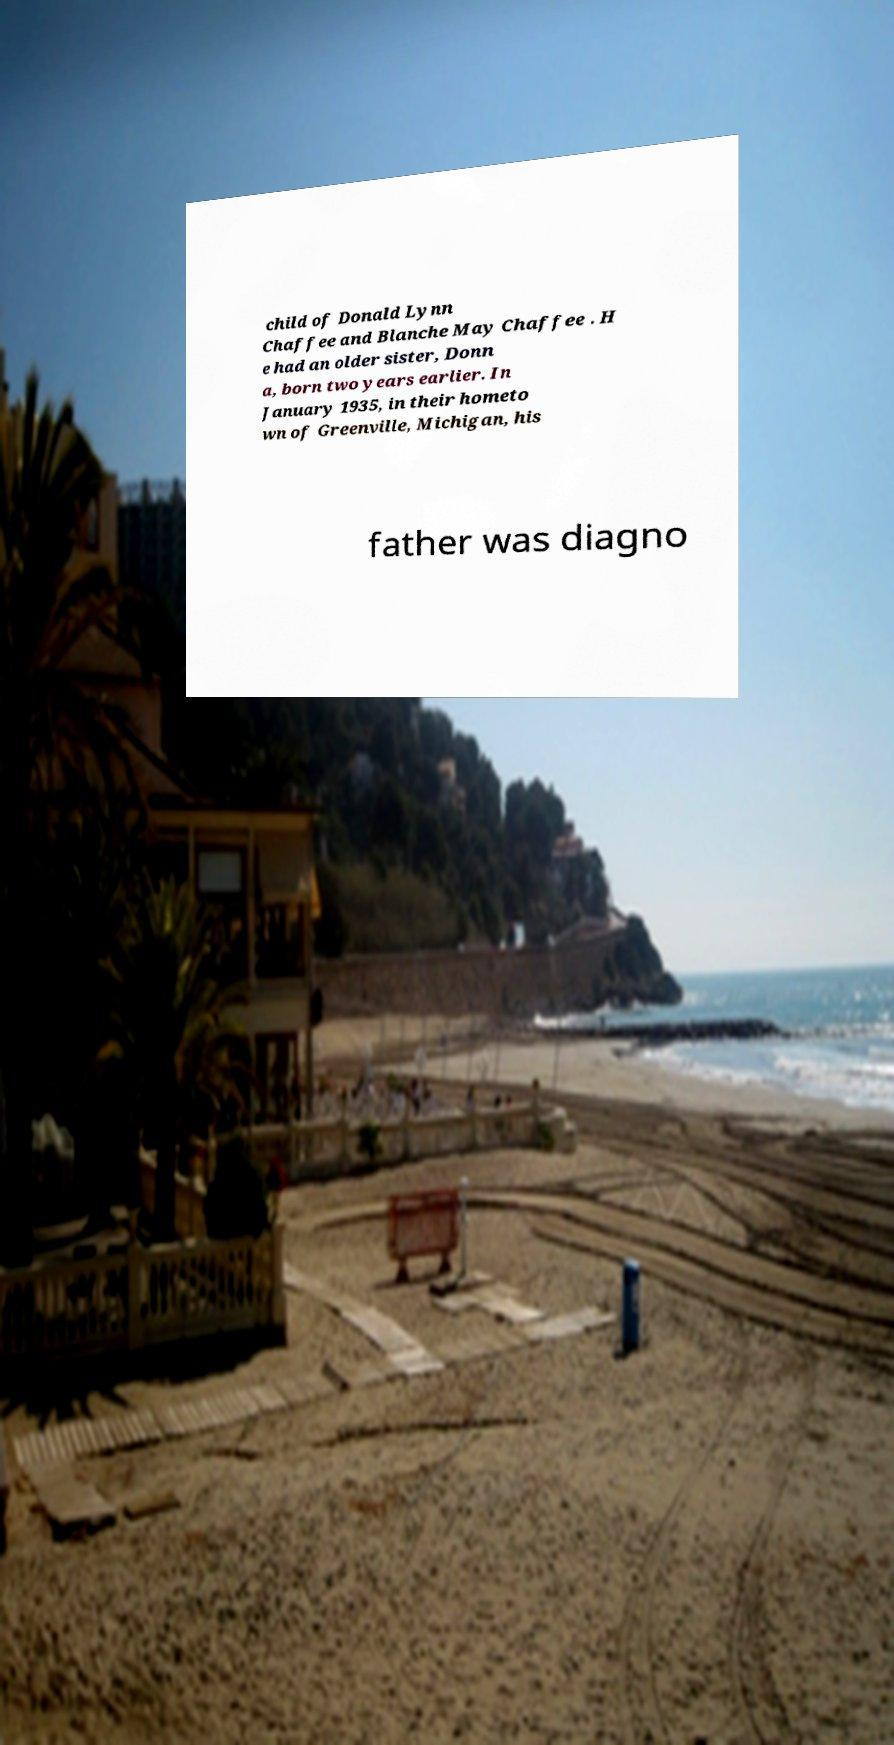Could you assist in decoding the text presented in this image and type it out clearly? child of Donald Lynn Chaffee and Blanche May Chaffee . H e had an older sister, Donn a, born two years earlier. In January 1935, in their hometo wn of Greenville, Michigan, his father was diagno 